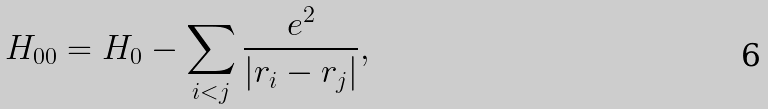Convert formula to latex. <formula><loc_0><loc_0><loc_500><loc_500>H _ { 0 0 } = H _ { 0 } - \sum _ { i < j } \frac { e ^ { 2 } } { \left | { r } _ { i } - { r } _ { j } \right | } ,</formula> 